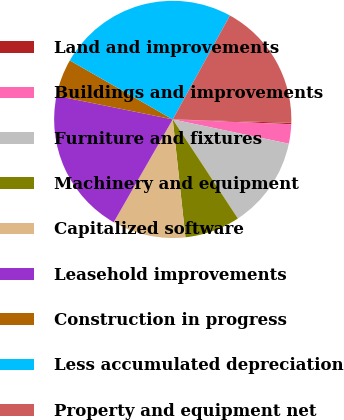Convert chart to OTSL. <chart><loc_0><loc_0><loc_500><loc_500><pie_chart><fcel>Land and improvements<fcel>Buildings and improvements<fcel>Furniture and fixtures<fcel>Machinery and equipment<fcel>Capitalized software<fcel>Leasehold improvements<fcel>Construction in progress<fcel>Less accumulated depreciation<fcel>Property and equipment net<nl><fcel>0.19%<fcel>2.64%<fcel>12.46%<fcel>7.55%<fcel>10.0%<fcel>19.9%<fcel>5.09%<fcel>24.73%<fcel>17.45%<nl></chart> 